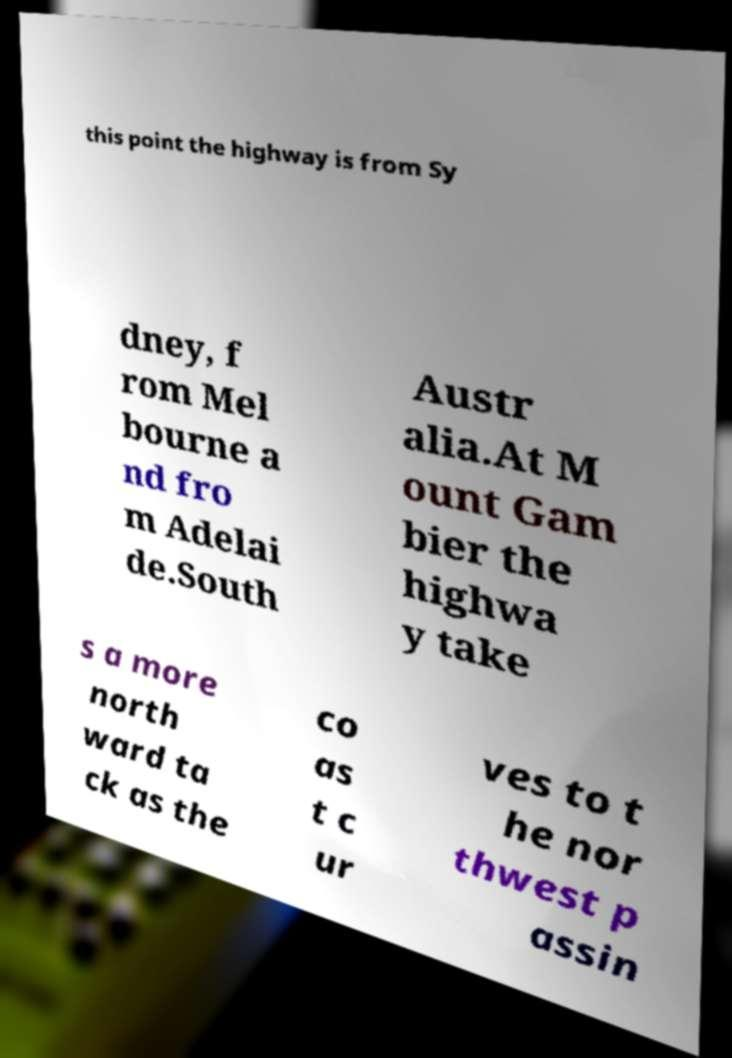What messages or text are displayed in this image? I need them in a readable, typed format. this point the highway is from Sy dney, f rom Mel bourne a nd fro m Adelai de.South Austr alia.At M ount Gam bier the highwa y take s a more north ward ta ck as the co as t c ur ves to t he nor thwest p assin 